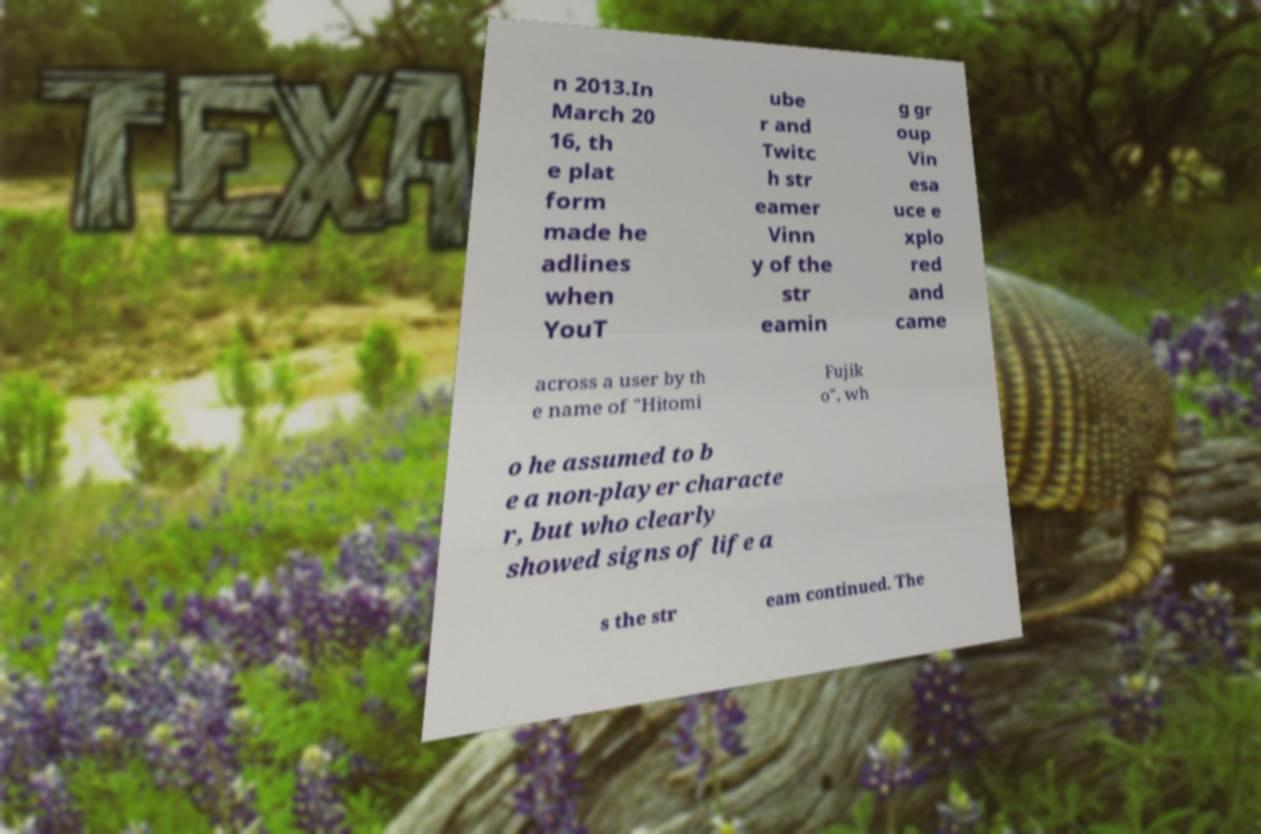There's text embedded in this image that I need extracted. Can you transcribe it verbatim? n 2013.In March 20 16, th e plat form made he adlines when YouT ube r and Twitc h str eamer Vinn y of the str eamin g gr oup Vin esa uce e xplo red and came across a user by th e name of "Hitomi Fujik o", wh o he assumed to b e a non-player characte r, but who clearly showed signs of life a s the str eam continued. The 